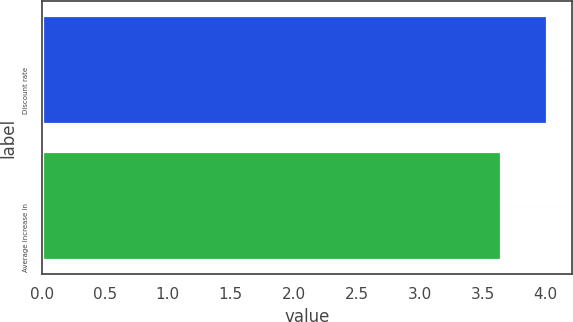<chart> <loc_0><loc_0><loc_500><loc_500><bar_chart><fcel>Discount rate<fcel>Average increase in<nl><fcel>4.01<fcel>3.65<nl></chart> 